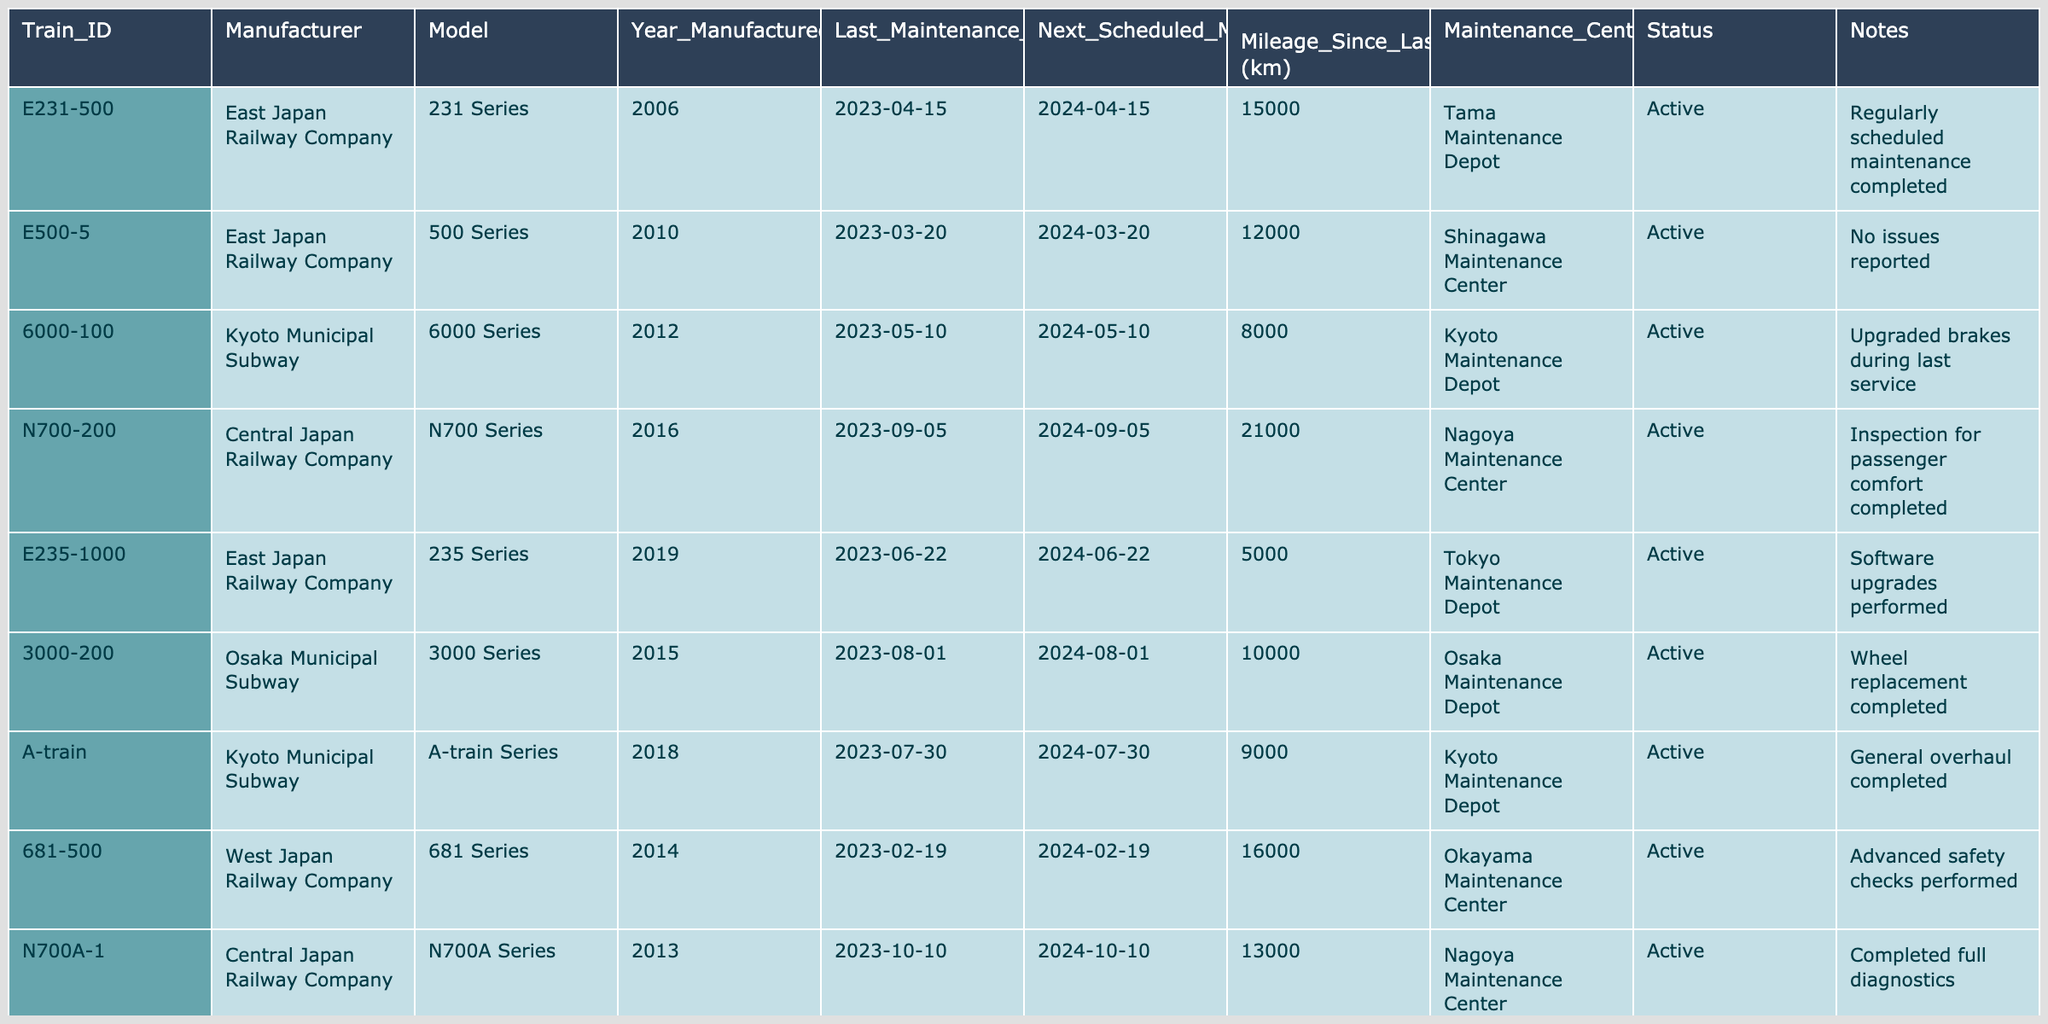What is the manufacturer of train E231-500? The row corresponding to train E231-500 indicates that it is manufactured by East Japan Railway Company.
Answer: East Japan Railway Company Which train has the highest mileage since its last maintenance? By examining the mileage since last maintenance for all trains listed, the train N700-200 has the highest mileage at 21,000 km.
Answer: N700-200 Is the status of train 681-500 active? The status column in the row for train 681-500 indicates that it is Active, confirming the statement is true.
Answer: Yes What is the average mileage since the last maintenance for all trains? The total mileage since last maintenance is 15000 + 12000 + 8000 + 21000 + 5000 + 10000 + 9000 + 16000 + 13000 + 11000 = 116000 km. There are 10 trains, so the average mileage is 116000 / 10 = 11600 km.
Answer: 11600 km Which maintenance center is responsible for train E500-5? The data shows that train E500-5 is maintained at the Shinagawa Maintenance Center.
Answer: Shinagawa Maintenance Center Have any trains scheduled between 2024-02-19 and 2024-09-05 undergone advanced safety checks? The row for train 681-500 shows that it underwent advanced safety checks and has its next scheduled maintenance on 2024-02-19. Additionally, the next maintenance for train N700-200, which is also between these dates, confirms that both underwent checks.
Answer: Yes How many trains were manufactured after 2015? By filtering the table for the Year Manufactured, we find that the trains manufactured after 2015 are E235-1000, 3000-200, A-train, and N700-200. Thus, there are 4 such trains.
Answer: 4 What is the difference in mileage since the last maintenance between the highest and lowest mileage trains? The highest mileage (21000 km for N700-200) and the lowest mileage (5000 km for E235-1000) provide a difference of 21000 - 5000 = 16000 km.
Answer: 16000 km Are all trains scheduled for their next maintenance before April 2024? Looking at the Next Scheduled Maintenance column, the dates indicate that no trains are scheduled after April 2024, confirming that all are before that date.
Answer: Yes 